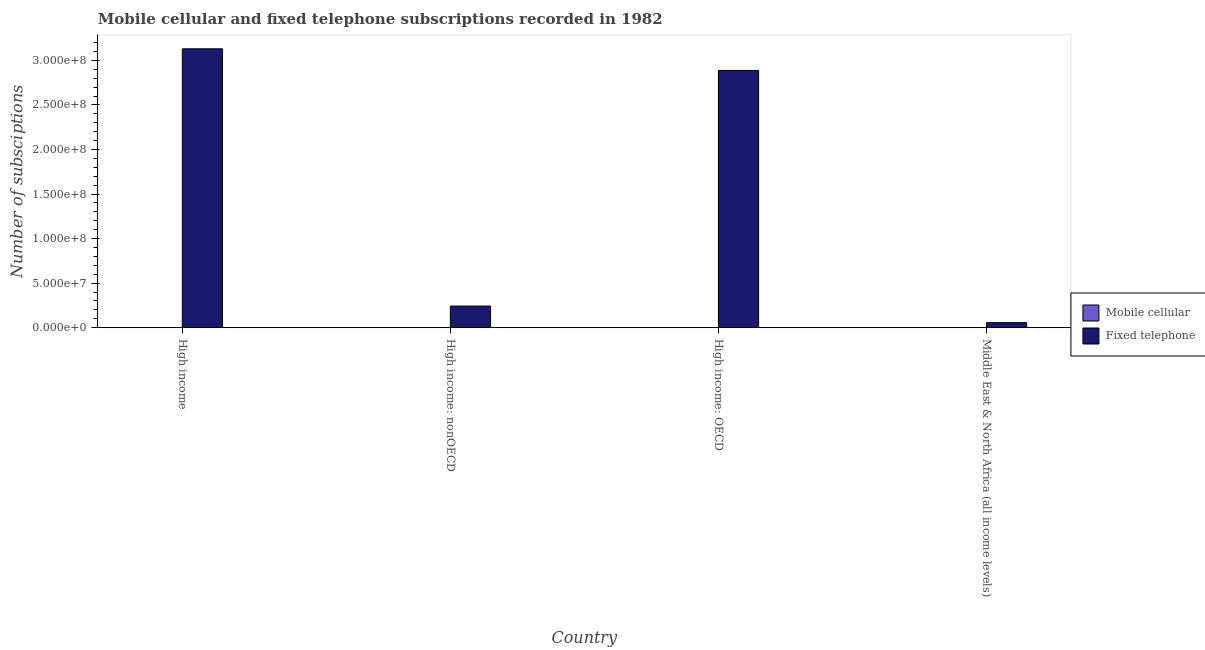How many groups of bars are there?
Make the answer very short. 4. What is the label of the 2nd group of bars from the left?
Give a very brief answer. High income: nonOECD. In how many cases, is the number of bars for a given country not equal to the number of legend labels?
Keep it short and to the point. 0. What is the number of mobile cellular subscriptions in High income: nonOECD?
Ensure brevity in your answer.  2330. Across all countries, what is the maximum number of mobile cellular subscriptions?
Offer a very short reply. 1.02e+05. Across all countries, what is the minimum number of fixed telephone subscriptions?
Your answer should be very brief. 5.67e+06. In which country was the number of fixed telephone subscriptions maximum?
Offer a terse response. High income. In which country was the number of fixed telephone subscriptions minimum?
Offer a terse response. Middle East & North Africa (all income levels). What is the total number of fixed telephone subscriptions in the graph?
Make the answer very short. 6.32e+08. What is the difference between the number of mobile cellular subscriptions in High income and that in Middle East & North Africa (all income levels)?
Give a very brief answer. 9.92e+04. What is the difference between the number of fixed telephone subscriptions in High income: OECD and the number of mobile cellular subscriptions in High income?
Ensure brevity in your answer.  2.89e+08. What is the average number of mobile cellular subscriptions per country?
Offer a very short reply. 5.13e+04. What is the difference between the number of fixed telephone subscriptions and number of mobile cellular subscriptions in High income?
Your answer should be very brief. 3.13e+08. In how many countries, is the number of fixed telephone subscriptions greater than 20000000 ?
Your answer should be very brief. 3. What is the ratio of the number of mobile cellular subscriptions in High income to that in High income: nonOECD?
Ensure brevity in your answer.  43.57. What is the difference between the highest and the second highest number of fixed telephone subscriptions?
Provide a succinct answer. 2.42e+07. What is the difference between the highest and the lowest number of fixed telephone subscriptions?
Provide a succinct answer. 3.07e+08. In how many countries, is the number of fixed telephone subscriptions greater than the average number of fixed telephone subscriptions taken over all countries?
Your answer should be compact. 2. What does the 1st bar from the left in High income represents?
Offer a very short reply. Mobile cellular. What does the 1st bar from the right in High income represents?
Keep it short and to the point. Fixed telephone. How many bars are there?
Your response must be concise. 8. Are all the bars in the graph horizontal?
Your answer should be compact. No. How many countries are there in the graph?
Provide a succinct answer. 4. What is the difference between two consecutive major ticks on the Y-axis?
Your answer should be very brief. 5.00e+07. Does the graph contain grids?
Keep it short and to the point. No. Where does the legend appear in the graph?
Make the answer very short. Center right. How many legend labels are there?
Give a very brief answer. 2. What is the title of the graph?
Make the answer very short. Mobile cellular and fixed telephone subscriptions recorded in 1982. Does "Revenue" appear as one of the legend labels in the graph?
Keep it short and to the point. No. What is the label or title of the X-axis?
Provide a short and direct response. Country. What is the label or title of the Y-axis?
Offer a terse response. Number of subsciptions. What is the Number of subsciptions of Mobile cellular in High income?
Your response must be concise. 1.02e+05. What is the Number of subsciptions in Fixed telephone in High income?
Your answer should be compact. 3.13e+08. What is the Number of subsciptions of Mobile cellular in High income: nonOECD?
Your answer should be very brief. 2330. What is the Number of subsciptions of Fixed telephone in High income: nonOECD?
Your response must be concise. 2.42e+07. What is the Number of subsciptions in Mobile cellular in High income: OECD?
Give a very brief answer. 9.92e+04. What is the Number of subsciptions in Fixed telephone in High income: OECD?
Provide a succinct answer. 2.89e+08. What is the Number of subsciptions of Mobile cellular in Middle East & North Africa (all income levels)?
Offer a very short reply. 2330. What is the Number of subsciptions of Fixed telephone in Middle East & North Africa (all income levels)?
Offer a terse response. 5.67e+06. Across all countries, what is the maximum Number of subsciptions of Mobile cellular?
Keep it short and to the point. 1.02e+05. Across all countries, what is the maximum Number of subsciptions of Fixed telephone?
Offer a very short reply. 3.13e+08. Across all countries, what is the minimum Number of subsciptions of Mobile cellular?
Make the answer very short. 2330. Across all countries, what is the minimum Number of subsciptions in Fixed telephone?
Offer a terse response. 5.67e+06. What is the total Number of subsciptions of Mobile cellular in the graph?
Offer a very short reply. 2.05e+05. What is the total Number of subsciptions in Fixed telephone in the graph?
Keep it short and to the point. 6.32e+08. What is the difference between the Number of subsciptions of Mobile cellular in High income and that in High income: nonOECD?
Give a very brief answer. 9.92e+04. What is the difference between the Number of subsciptions in Fixed telephone in High income and that in High income: nonOECD?
Your answer should be very brief. 2.89e+08. What is the difference between the Number of subsciptions in Mobile cellular in High income and that in High income: OECD?
Give a very brief answer. 2330. What is the difference between the Number of subsciptions in Fixed telephone in High income and that in High income: OECD?
Offer a very short reply. 2.42e+07. What is the difference between the Number of subsciptions of Mobile cellular in High income and that in Middle East & North Africa (all income levels)?
Offer a terse response. 9.92e+04. What is the difference between the Number of subsciptions of Fixed telephone in High income and that in Middle East & North Africa (all income levels)?
Offer a terse response. 3.07e+08. What is the difference between the Number of subsciptions of Mobile cellular in High income: nonOECD and that in High income: OECD?
Provide a succinct answer. -9.68e+04. What is the difference between the Number of subsciptions in Fixed telephone in High income: nonOECD and that in High income: OECD?
Provide a short and direct response. -2.64e+08. What is the difference between the Number of subsciptions in Fixed telephone in High income: nonOECD and that in Middle East & North Africa (all income levels)?
Offer a terse response. 1.86e+07. What is the difference between the Number of subsciptions of Mobile cellular in High income: OECD and that in Middle East & North Africa (all income levels)?
Your response must be concise. 9.68e+04. What is the difference between the Number of subsciptions in Fixed telephone in High income: OECD and that in Middle East & North Africa (all income levels)?
Provide a short and direct response. 2.83e+08. What is the difference between the Number of subsciptions in Mobile cellular in High income and the Number of subsciptions in Fixed telephone in High income: nonOECD?
Give a very brief answer. -2.41e+07. What is the difference between the Number of subsciptions in Mobile cellular in High income and the Number of subsciptions in Fixed telephone in High income: OECD?
Ensure brevity in your answer.  -2.89e+08. What is the difference between the Number of subsciptions in Mobile cellular in High income and the Number of subsciptions in Fixed telephone in Middle East & North Africa (all income levels)?
Ensure brevity in your answer.  -5.57e+06. What is the difference between the Number of subsciptions in Mobile cellular in High income: nonOECD and the Number of subsciptions in Fixed telephone in High income: OECD?
Keep it short and to the point. -2.89e+08. What is the difference between the Number of subsciptions of Mobile cellular in High income: nonOECD and the Number of subsciptions of Fixed telephone in Middle East & North Africa (all income levels)?
Offer a terse response. -5.67e+06. What is the difference between the Number of subsciptions in Mobile cellular in High income: OECD and the Number of subsciptions in Fixed telephone in Middle East & North Africa (all income levels)?
Your answer should be very brief. -5.57e+06. What is the average Number of subsciptions in Mobile cellular per country?
Provide a succinct answer. 5.13e+04. What is the average Number of subsciptions in Fixed telephone per country?
Provide a short and direct response. 1.58e+08. What is the difference between the Number of subsciptions in Mobile cellular and Number of subsciptions in Fixed telephone in High income?
Offer a terse response. -3.13e+08. What is the difference between the Number of subsciptions of Mobile cellular and Number of subsciptions of Fixed telephone in High income: nonOECD?
Your answer should be compact. -2.42e+07. What is the difference between the Number of subsciptions of Mobile cellular and Number of subsciptions of Fixed telephone in High income: OECD?
Offer a terse response. -2.89e+08. What is the difference between the Number of subsciptions of Mobile cellular and Number of subsciptions of Fixed telephone in Middle East & North Africa (all income levels)?
Provide a short and direct response. -5.67e+06. What is the ratio of the Number of subsciptions in Mobile cellular in High income to that in High income: nonOECD?
Give a very brief answer. 43.57. What is the ratio of the Number of subsciptions of Fixed telephone in High income to that in High income: nonOECD?
Your response must be concise. 12.91. What is the ratio of the Number of subsciptions of Mobile cellular in High income to that in High income: OECD?
Provide a succinct answer. 1.02. What is the ratio of the Number of subsciptions in Fixed telephone in High income to that in High income: OECD?
Ensure brevity in your answer.  1.08. What is the ratio of the Number of subsciptions of Mobile cellular in High income to that in Middle East & North Africa (all income levels)?
Offer a very short reply. 43.57. What is the ratio of the Number of subsciptions in Fixed telephone in High income to that in Middle East & North Africa (all income levels)?
Keep it short and to the point. 55.22. What is the ratio of the Number of subsciptions of Mobile cellular in High income: nonOECD to that in High income: OECD?
Make the answer very short. 0.02. What is the ratio of the Number of subsciptions of Fixed telephone in High income: nonOECD to that in High income: OECD?
Your answer should be very brief. 0.08. What is the ratio of the Number of subsciptions of Fixed telephone in High income: nonOECD to that in Middle East & North Africa (all income levels)?
Ensure brevity in your answer.  4.28. What is the ratio of the Number of subsciptions of Mobile cellular in High income: OECD to that in Middle East & North Africa (all income levels)?
Ensure brevity in your answer.  42.57. What is the ratio of the Number of subsciptions in Fixed telephone in High income: OECD to that in Middle East & North Africa (all income levels)?
Provide a succinct answer. 50.94. What is the difference between the highest and the second highest Number of subsciptions in Mobile cellular?
Offer a terse response. 2330. What is the difference between the highest and the second highest Number of subsciptions of Fixed telephone?
Give a very brief answer. 2.42e+07. What is the difference between the highest and the lowest Number of subsciptions of Mobile cellular?
Your answer should be very brief. 9.92e+04. What is the difference between the highest and the lowest Number of subsciptions in Fixed telephone?
Offer a terse response. 3.07e+08. 